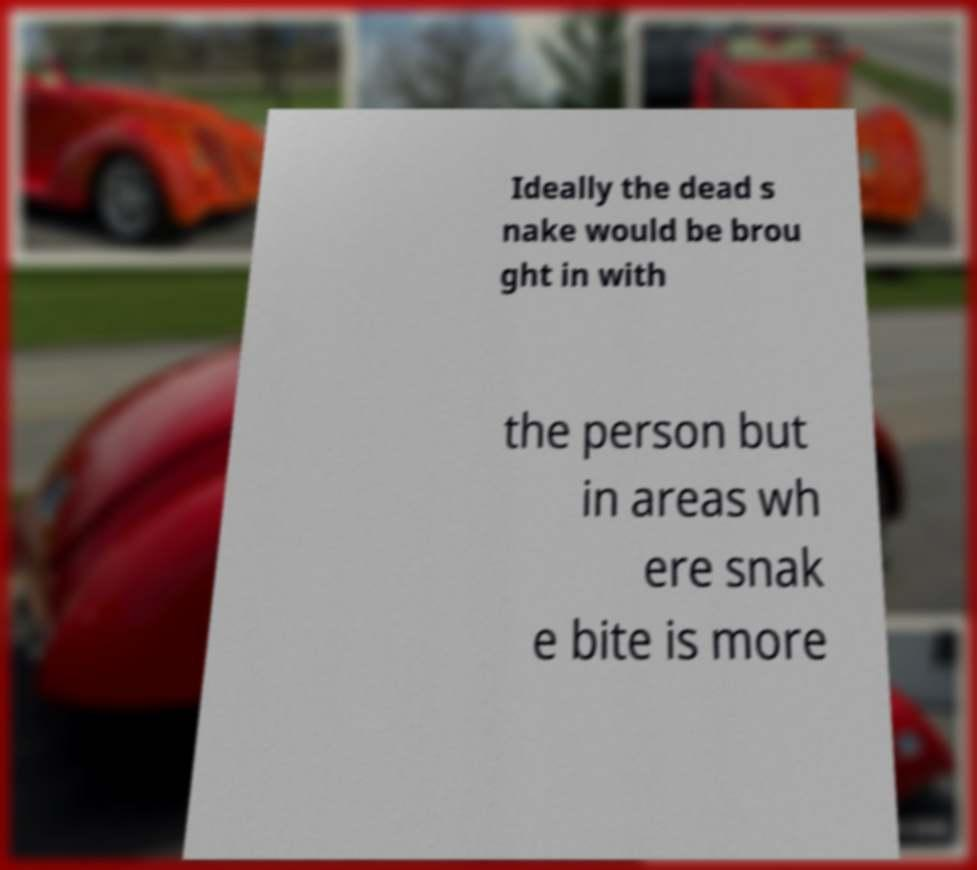For documentation purposes, I need the text within this image transcribed. Could you provide that? Ideally the dead s nake would be brou ght in with the person but in areas wh ere snak e bite is more 